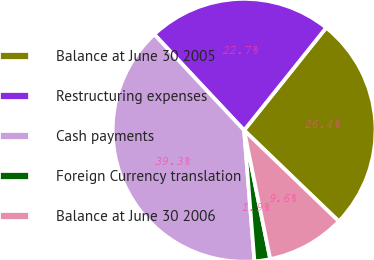Convert chart. <chart><loc_0><loc_0><loc_500><loc_500><pie_chart><fcel>Balance at June 30 2005<fcel>Restructuring expenses<fcel>Cash payments<fcel>Foreign Currency translation<fcel>Balance at June 30 2006<nl><fcel>26.45%<fcel>22.72%<fcel>39.28%<fcel>1.93%<fcel>9.63%<nl></chart> 